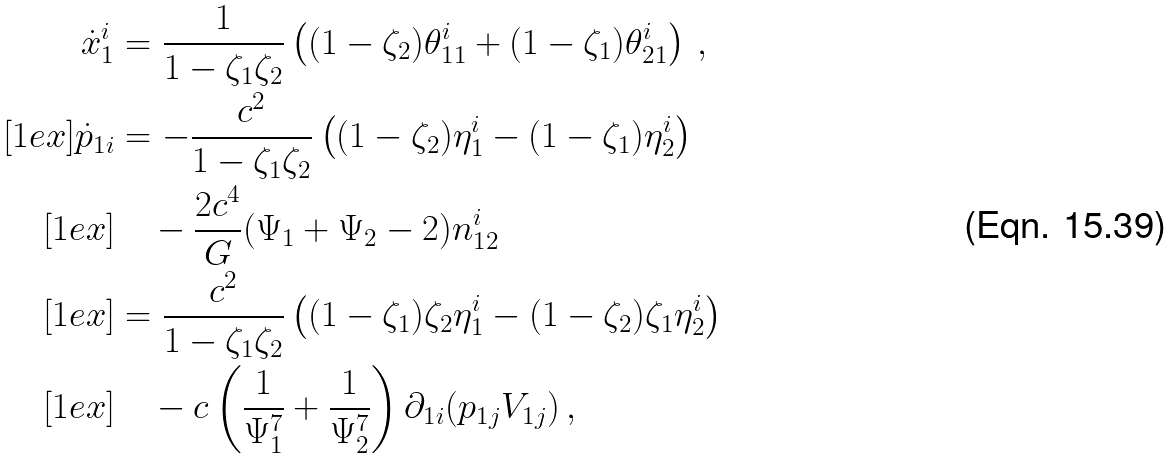<formula> <loc_0><loc_0><loc_500><loc_500>\dot { x } _ { 1 } ^ { i } & = \frac { 1 } { 1 - \zeta _ { 1 } \zeta _ { 2 } } \left ( ( 1 - \zeta _ { 2 } ) \theta _ { 1 1 } ^ { i } + ( 1 - \zeta _ { 1 } ) \theta _ { 2 1 } ^ { i } \right ) \, , \\ [ 1 e x ] \dot { p } _ { 1 i } & = - \frac { c ^ { 2 } } { 1 - \zeta _ { 1 } \zeta _ { 2 } } \left ( ( 1 - \zeta _ { 2 } ) \eta _ { 1 } ^ { i } - ( 1 - \zeta _ { 1 } ) \eta _ { 2 } ^ { i } \right ) \\ [ 1 e x ] & \quad - \frac { 2 c ^ { 4 } } { G } ( \Psi _ { 1 } + \Psi _ { 2 } - 2 ) n _ { 1 2 } ^ { i } \\ [ 1 e x ] & = \frac { c ^ { 2 } } { 1 - \zeta _ { 1 } \zeta _ { 2 } } \left ( ( 1 - \zeta _ { 1 } ) \zeta _ { 2 } \eta _ { 1 } ^ { i } - ( 1 - \zeta _ { 2 } ) \zeta _ { 1 } \eta _ { 2 } ^ { i } \right ) \\ [ 1 e x ] & \quad - c \left ( \frac { 1 } { \Psi _ { 1 } ^ { 7 } } + \frac { 1 } { \Psi _ { 2 } ^ { 7 } } \right ) \partial _ { 1 i } ( p _ { 1 j } V _ { 1 j } ) \, ,</formula> 